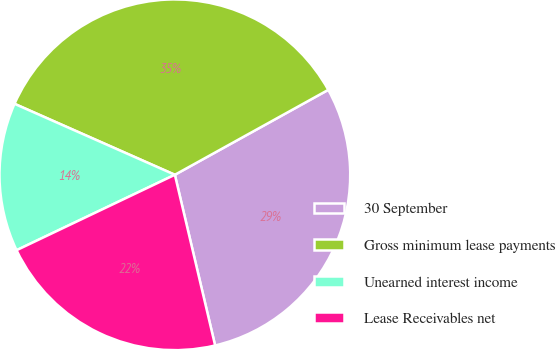<chart> <loc_0><loc_0><loc_500><loc_500><pie_chart><fcel>30 September<fcel>Gross minimum lease payments<fcel>Unearned interest income<fcel>Lease Receivables net<nl><fcel>29.36%<fcel>35.32%<fcel>13.71%<fcel>21.61%<nl></chart> 